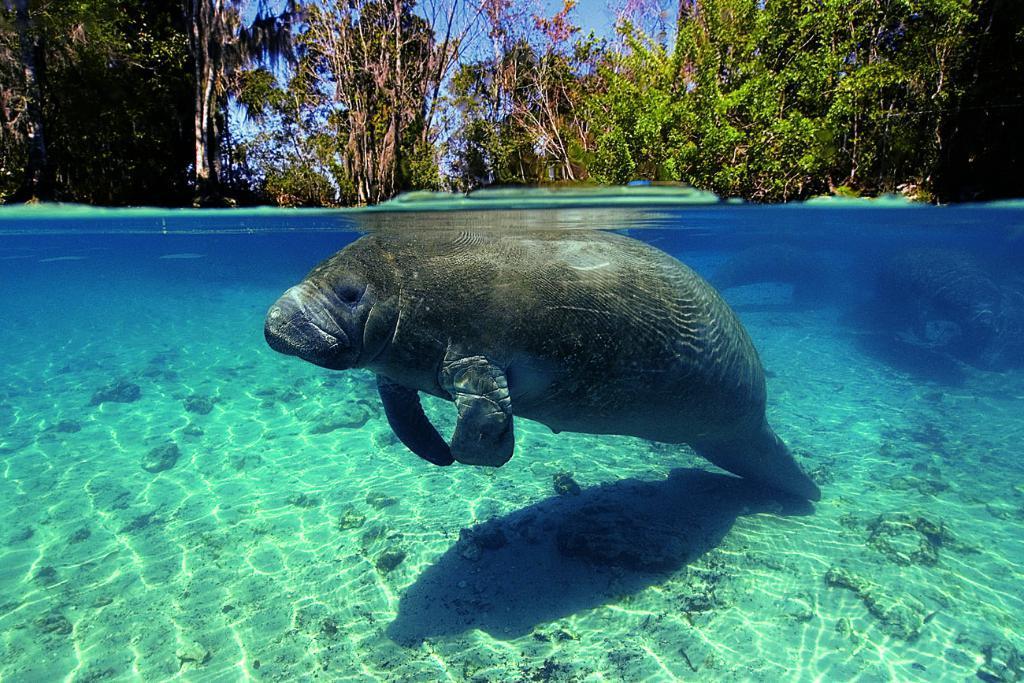Describe this image in one or two sentences. In the middle I can see a fish in the water. In the background I can see trees and the sky. This image is taken may be during a day. 